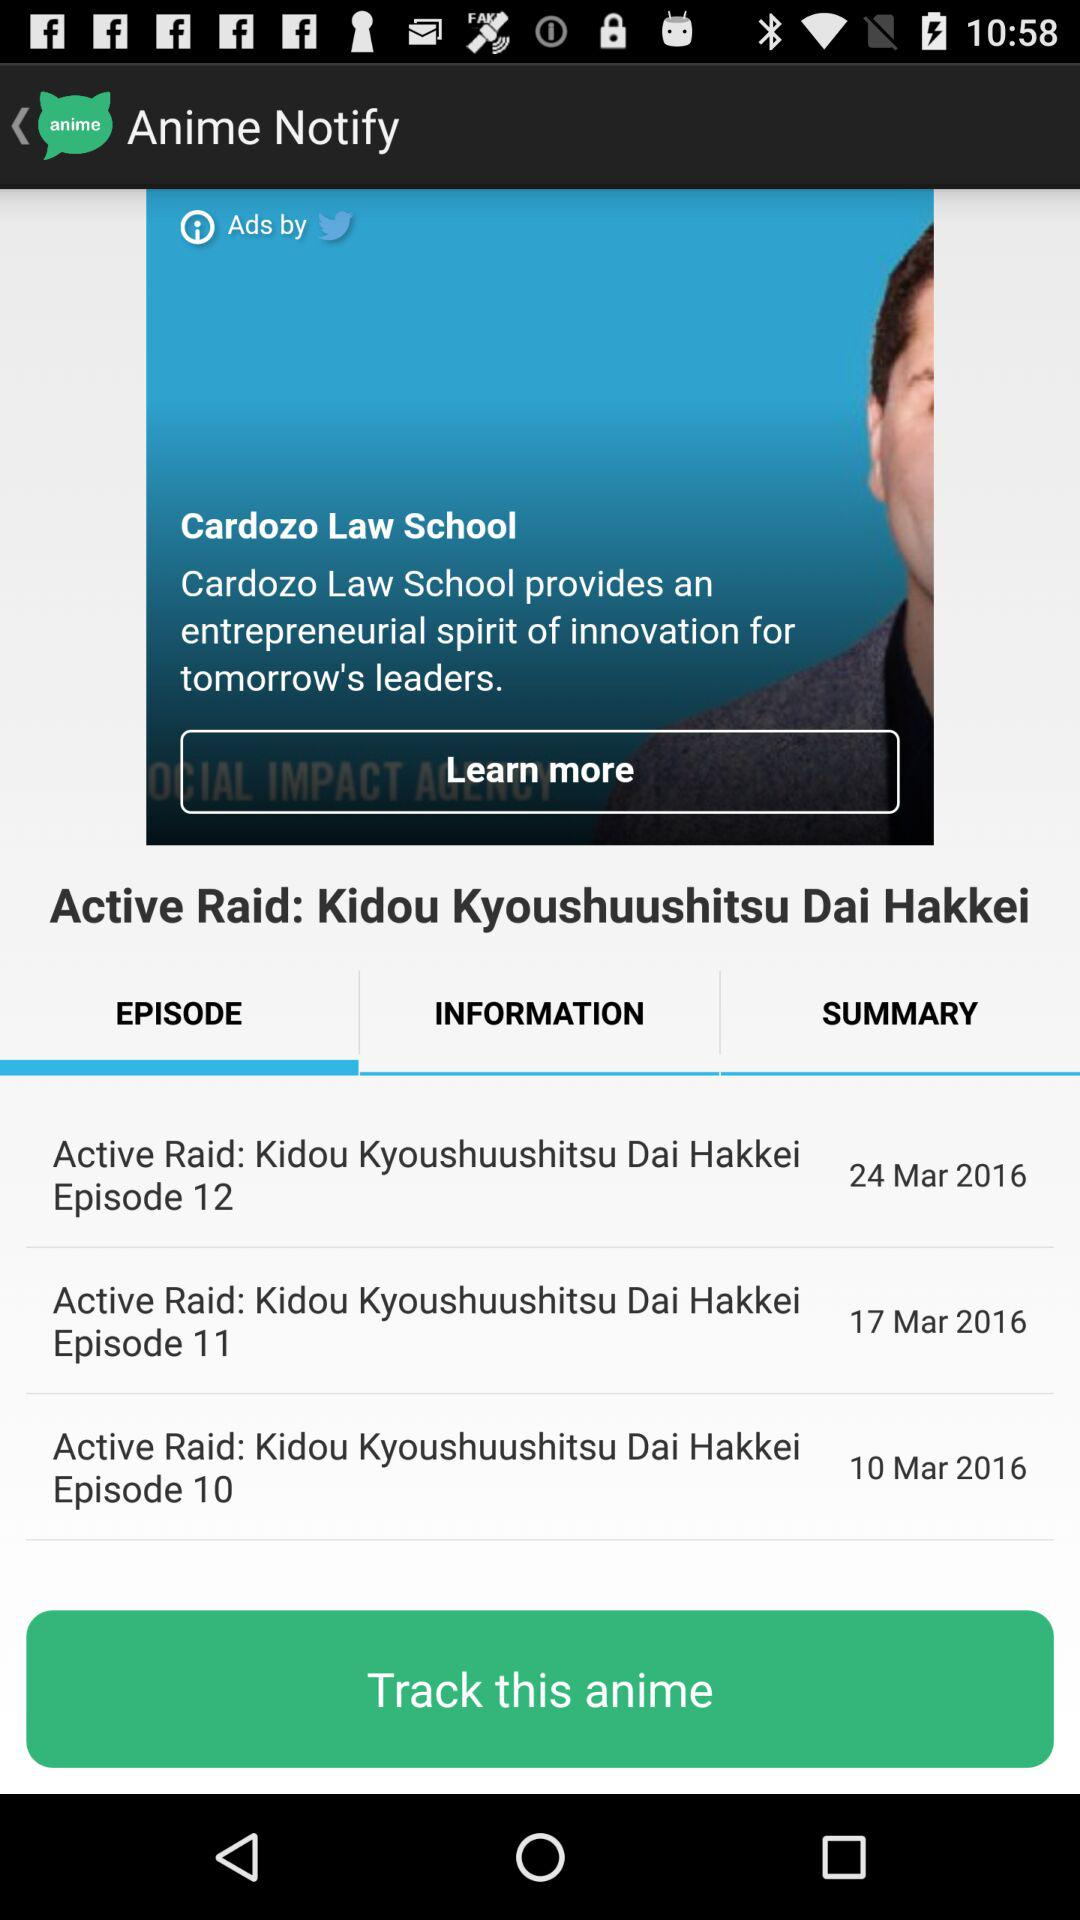What is the name of Episode 12? The name of episode 12 is Active Raid: Kidou Kyoushuushitsu Dai Hakkie. 